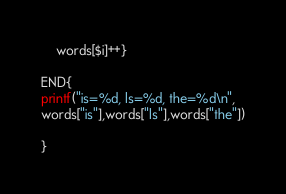<code> <loc_0><loc_0><loc_500><loc_500><_Awk_>	words[$i]++}

END{
printf("is=%d, ls=%d, the=%d\n",
words["is"],words["ls"],words["the"])

}
</code> 